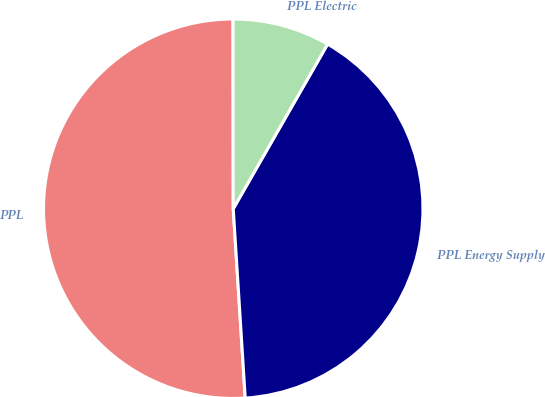<chart> <loc_0><loc_0><loc_500><loc_500><pie_chart><fcel>PPL<fcel>PPL Energy Supply<fcel>PPL Electric<nl><fcel>50.99%<fcel>40.71%<fcel>8.3%<nl></chart> 